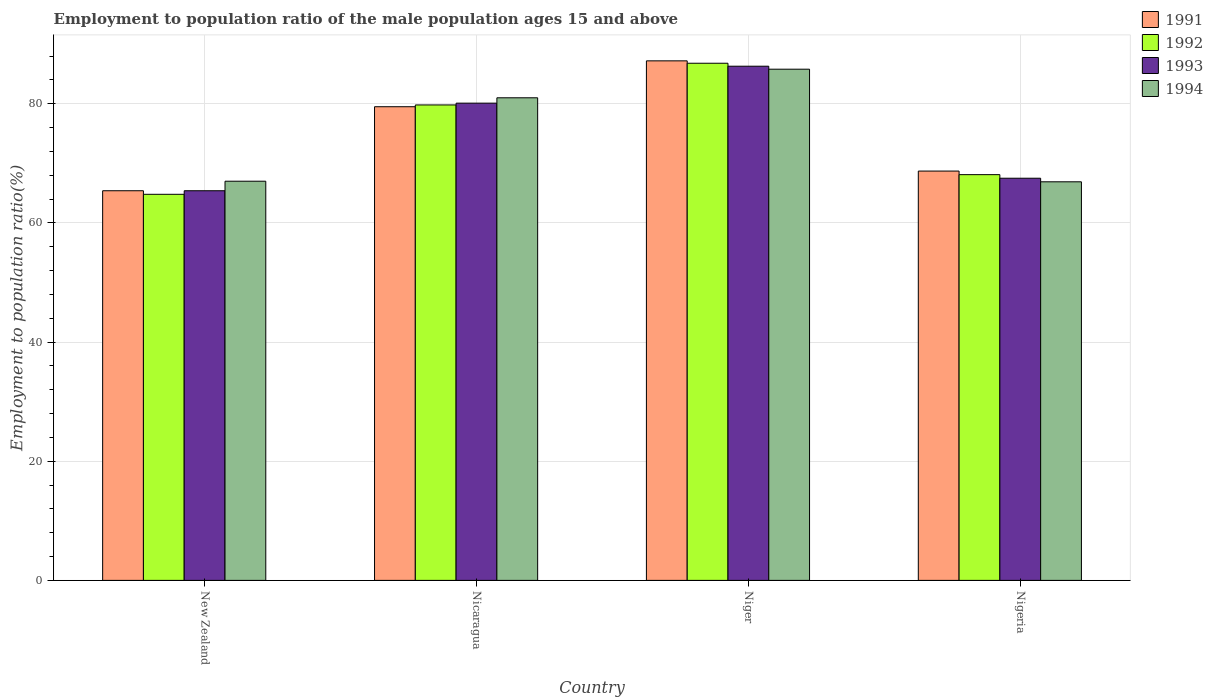How many different coloured bars are there?
Your response must be concise. 4. How many groups of bars are there?
Provide a short and direct response. 4. Are the number of bars on each tick of the X-axis equal?
Offer a terse response. Yes. How many bars are there on the 4th tick from the right?
Offer a terse response. 4. What is the label of the 2nd group of bars from the left?
Ensure brevity in your answer.  Nicaragua. In how many cases, is the number of bars for a given country not equal to the number of legend labels?
Ensure brevity in your answer.  0. What is the employment to population ratio in 1991 in Nicaragua?
Your answer should be compact. 79.5. Across all countries, what is the maximum employment to population ratio in 1991?
Make the answer very short. 87.2. Across all countries, what is the minimum employment to population ratio in 1993?
Give a very brief answer. 65.4. In which country was the employment to population ratio in 1993 maximum?
Provide a short and direct response. Niger. In which country was the employment to population ratio in 1993 minimum?
Offer a very short reply. New Zealand. What is the total employment to population ratio in 1992 in the graph?
Your response must be concise. 299.5. What is the difference between the employment to population ratio in 1993 in New Zealand and that in Nigeria?
Your response must be concise. -2.1. What is the difference between the employment to population ratio in 1991 in New Zealand and the employment to population ratio in 1992 in Nicaragua?
Provide a succinct answer. -14.4. What is the average employment to population ratio in 1991 per country?
Make the answer very short. 75.2. What is the difference between the employment to population ratio of/in 1991 and employment to population ratio of/in 1992 in Niger?
Provide a succinct answer. 0.4. What is the ratio of the employment to population ratio in 1991 in Nicaragua to that in Nigeria?
Your answer should be very brief. 1.16. Is the employment to population ratio in 1993 in Nicaragua less than that in Nigeria?
Offer a very short reply. No. Is the difference between the employment to population ratio in 1991 in Nicaragua and Nigeria greater than the difference between the employment to population ratio in 1992 in Nicaragua and Nigeria?
Your response must be concise. No. What is the difference between the highest and the second highest employment to population ratio in 1994?
Make the answer very short. 14. What is the difference between the highest and the lowest employment to population ratio in 1994?
Provide a short and direct response. 18.9. In how many countries, is the employment to population ratio in 1992 greater than the average employment to population ratio in 1992 taken over all countries?
Provide a short and direct response. 2. Is the sum of the employment to population ratio in 1991 in Nicaragua and Niger greater than the maximum employment to population ratio in 1992 across all countries?
Ensure brevity in your answer.  Yes. What does the 2nd bar from the left in Nicaragua represents?
Give a very brief answer. 1992. What does the 3rd bar from the right in New Zealand represents?
Keep it short and to the point. 1992. How many countries are there in the graph?
Your response must be concise. 4. Does the graph contain grids?
Your answer should be very brief. Yes. Where does the legend appear in the graph?
Offer a terse response. Top right. How many legend labels are there?
Your response must be concise. 4. What is the title of the graph?
Make the answer very short. Employment to population ratio of the male population ages 15 and above. What is the Employment to population ratio(%) in 1991 in New Zealand?
Offer a very short reply. 65.4. What is the Employment to population ratio(%) in 1992 in New Zealand?
Your response must be concise. 64.8. What is the Employment to population ratio(%) of 1993 in New Zealand?
Give a very brief answer. 65.4. What is the Employment to population ratio(%) of 1994 in New Zealand?
Your answer should be compact. 67. What is the Employment to population ratio(%) of 1991 in Nicaragua?
Your answer should be compact. 79.5. What is the Employment to population ratio(%) in 1992 in Nicaragua?
Make the answer very short. 79.8. What is the Employment to population ratio(%) of 1993 in Nicaragua?
Your answer should be very brief. 80.1. What is the Employment to population ratio(%) in 1991 in Niger?
Keep it short and to the point. 87.2. What is the Employment to population ratio(%) of 1992 in Niger?
Offer a very short reply. 86.8. What is the Employment to population ratio(%) of 1993 in Niger?
Keep it short and to the point. 86.3. What is the Employment to population ratio(%) of 1994 in Niger?
Your answer should be compact. 85.8. What is the Employment to population ratio(%) in 1991 in Nigeria?
Your response must be concise. 68.7. What is the Employment to population ratio(%) in 1992 in Nigeria?
Offer a terse response. 68.1. What is the Employment to population ratio(%) in 1993 in Nigeria?
Offer a terse response. 67.5. What is the Employment to population ratio(%) of 1994 in Nigeria?
Ensure brevity in your answer.  66.9. Across all countries, what is the maximum Employment to population ratio(%) in 1991?
Your response must be concise. 87.2. Across all countries, what is the maximum Employment to population ratio(%) in 1992?
Provide a short and direct response. 86.8. Across all countries, what is the maximum Employment to population ratio(%) in 1993?
Your response must be concise. 86.3. Across all countries, what is the maximum Employment to population ratio(%) in 1994?
Your answer should be compact. 85.8. Across all countries, what is the minimum Employment to population ratio(%) in 1991?
Provide a succinct answer. 65.4. Across all countries, what is the minimum Employment to population ratio(%) of 1992?
Provide a succinct answer. 64.8. Across all countries, what is the minimum Employment to population ratio(%) of 1993?
Provide a short and direct response. 65.4. Across all countries, what is the minimum Employment to population ratio(%) of 1994?
Ensure brevity in your answer.  66.9. What is the total Employment to population ratio(%) in 1991 in the graph?
Give a very brief answer. 300.8. What is the total Employment to population ratio(%) of 1992 in the graph?
Provide a short and direct response. 299.5. What is the total Employment to population ratio(%) of 1993 in the graph?
Offer a terse response. 299.3. What is the total Employment to population ratio(%) in 1994 in the graph?
Keep it short and to the point. 300.7. What is the difference between the Employment to population ratio(%) in 1991 in New Zealand and that in Nicaragua?
Give a very brief answer. -14.1. What is the difference between the Employment to population ratio(%) of 1993 in New Zealand and that in Nicaragua?
Your answer should be very brief. -14.7. What is the difference between the Employment to population ratio(%) of 1991 in New Zealand and that in Niger?
Your answer should be very brief. -21.8. What is the difference between the Employment to population ratio(%) in 1993 in New Zealand and that in Niger?
Offer a very short reply. -20.9. What is the difference between the Employment to population ratio(%) in 1994 in New Zealand and that in Niger?
Offer a very short reply. -18.8. What is the difference between the Employment to population ratio(%) of 1991 in New Zealand and that in Nigeria?
Your answer should be compact. -3.3. What is the difference between the Employment to population ratio(%) of 1993 in New Zealand and that in Nigeria?
Keep it short and to the point. -2.1. What is the difference between the Employment to population ratio(%) of 1992 in Nicaragua and that in Niger?
Provide a succinct answer. -7. What is the difference between the Employment to population ratio(%) in 1993 in Nicaragua and that in Niger?
Your response must be concise. -6.2. What is the difference between the Employment to population ratio(%) in 1994 in Nicaragua and that in Niger?
Make the answer very short. -4.8. What is the difference between the Employment to population ratio(%) in 1991 in Niger and that in Nigeria?
Your response must be concise. 18.5. What is the difference between the Employment to population ratio(%) of 1992 in Niger and that in Nigeria?
Your answer should be very brief. 18.7. What is the difference between the Employment to population ratio(%) of 1993 in Niger and that in Nigeria?
Keep it short and to the point. 18.8. What is the difference between the Employment to population ratio(%) in 1991 in New Zealand and the Employment to population ratio(%) in 1992 in Nicaragua?
Offer a very short reply. -14.4. What is the difference between the Employment to population ratio(%) of 1991 in New Zealand and the Employment to population ratio(%) of 1993 in Nicaragua?
Provide a short and direct response. -14.7. What is the difference between the Employment to population ratio(%) in 1991 in New Zealand and the Employment to population ratio(%) in 1994 in Nicaragua?
Provide a short and direct response. -15.6. What is the difference between the Employment to population ratio(%) in 1992 in New Zealand and the Employment to population ratio(%) in 1993 in Nicaragua?
Provide a succinct answer. -15.3. What is the difference between the Employment to population ratio(%) in 1992 in New Zealand and the Employment to population ratio(%) in 1994 in Nicaragua?
Your answer should be compact. -16.2. What is the difference between the Employment to population ratio(%) in 1993 in New Zealand and the Employment to population ratio(%) in 1994 in Nicaragua?
Your answer should be very brief. -15.6. What is the difference between the Employment to population ratio(%) in 1991 in New Zealand and the Employment to population ratio(%) in 1992 in Niger?
Ensure brevity in your answer.  -21.4. What is the difference between the Employment to population ratio(%) of 1991 in New Zealand and the Employment to population ratio(%) of 1993 in Niger?
Offer a very short reply. -20.9. What is the difference between the Employment to population ratio(%) of 1991 in New Zealand and the Employment to population ratio(%) of 1994 in Niger?
Ensure brevity in your answer.  -20.4. What is the difference between the Employment to population ratio(%) in 1992 in New Zealand and the Employment to population ratio(%) in 1993 in Niger?
Your answer should be compact. -21.5. What is the difference between the Employment to population ratio(%) of 1993 in New Zealand and the Employment to population ratio(%) of 1994 in Niger?
Keep it short and to the point. -20.4. What is the difference between the Employment to population ratio(%) of 1991 in New Zealand and the Employment to population ratio(%) of 1992 in Nigeria?
Provide a succinct answer. -2.7. What is the difference between the Employment to population ratio(%) of 1991 in New Zealand and the Employment to population ratio(%) of 1993 in Nigeria?
Provide a succinct answer. -2.1. What is the difference between the Employment to population ratio(%) of 1991 in New Zealand and the Employment to population ratio(%) of 1994 in Nigeria?
Give a very brief answer. -1.5. What is the difference between the Employment to population ratio(%) in 1992 in New Zealand and the Employment to population ratio(%) in 1994 in Nigeria?
Ensure brevity in your answer.  -2.1. What is the difference between the Employment to population ratio(%) in 1991 in Nicaragua and the Employment to population ratio(%) in 1993 in Niger?
Your response must be concise. -6.8. What is the difference between the Employment to population ratio(%) of 1991 in Nicaragua and the Employment to population ratio(%) of 1994 in Niger?
Offer a very short reply. -6.3. What is the difference between the Employment to population ratio(%) in 1992 in Nicaragua and the Employment to population ratio(%) in 1994 in Niger?
Ensure brevity in your answer.  -6. What is the difference between the Employment to population ratio(%) of 1991 in Nicaragua and the Employment to population ratio(%) of 1994 in Nigeria?
Your answer should be compact. 12.6. What is the difference between the Employment to population ratio(%) of 1991 in Niger and the Employment to population ratio(%) of 1993 in Nigeria?
Your answer should be compact. 19.7. What is the difference between the Employment to population ratio(%) of 1991 in Niger and the Employment to population ratio(%) of 1994 in Nigeria?
Your response must be concise. 20.3. What is the difference between the Employment to population ratio(%) of 1992 in Niger and the Employment to population ratio(%) of 1993 in Nigeria?
Provide a short and direct response. 19.3. What is the difference between the Employment to population ratio(%) of 1992 in Niger and the Employment to population ratio(%) of 1994 in Nigeria?
Keep it short and to the point. 19.9. What is the average Employment to population ratio(%) of 1991 per country?
Provide a short and direct response. 75.2. What is the average Employment to population ratio(%) of 1992 per country?
Make the answer very short. 74.88. What is the average Employment to population ratio(%) of 1993 per country?
Offer a terse response. 74.83. What is the average Employment to population ratio(%) in 1994 per country?
Ensure brevity in your answer.  75.17. What is the difference between the Employment to population ratio(%) in 1991 and Employment to population ratio(%) in 1993 in New Zealand?
Keep it short and to the point. 0. What is the difference between the Employment to population ratio(%) in 1992 and Employment to population ratio(%) in 1994 in New Zealand?
Offer a very short reply. -2.2. What is the difference between the Employment to population ratio(%) of 1991 and Employment to population ratio(%) of 1992 in Nicaragua?
Your response must be concise. -0.3. What is the difference between the Employment to population ratio(%) of 1991 and Employment to population ratio(%) of 1993 in Nicaragua?
Provide a succinct answer. -0.6. What is the difference between the Employment to population ratio(%) in 1991 and Employment to population ratio(%) in 1994 in Nicaragua?
Your answer should be compact. -1.5. What is the difference between the Employment to population ratio(%) in 1993 and Employment to population ratio(%) in 1994 in Nicaragua?
Ensure brevity in your answer.  -0.9. What is the difference between the Employment to population ratio(%) of 1992 and Employment to population ratio(%) of 1993 in Niger?
Keep it short and to the point. 0.5. What is the difference between the Employment to population ratio(%) of 1992 and Employment to population ratio(%) of 1994 in Niger?
Provide a succinct answer. 1. What is the difference between the Employment to population ratio(%) in 1993 and Employment to population ratio(%) in 1994 in Niger?
Give a very brief answer. 0.5. What is the difference between the Employment to population ratio(%) of 1991 and Employment to population ratio(%) of 1992 in Nigeria?
Offer a very short reply. 0.6. What is the difference between the Employment to population ratio(%) in 1991 and Employment to population ratio(%) in 1993 in Nigeria?
Offer a very short reply. 1.2. What is the ratio of the Employment to population ratio(%) in 1991 in New Zealand to that in Nicaragua?
Make the answer very short. 0.82. What is the ratio of the Employment to population ratio(%) of 1992 in New Zealand to that in Nicaragua?
Keep it short and to the point. 0.81. What is the ratio of the Employment to population ratio(%) of 1993 in New Zealand to that in Nicaragua?
Your answer should be compact. 0.82. What is the ratio of the Employment to population ratio(%) in 1994 in New Zealand to that in Nicaragua?
Your answer should be very brief. 0.83. What is the ratio of the Employment to population ratio(%) of 1992 in New Zealand to that in Niger?
Your answer should be compact. 0.75. What is the ratio of the Employment to population ratio(%) in 1993 in New Zealand to that in Niger?
Give a very brief answer. 0.76. What is the ratio of the Employment to population ratio(%) of 1994 in New Zealand to that in Niger?
Your answer should be compact. 0.78. What is the ratio of the Employment to population ratio(%) in 1991 in New Zealand to that in Nigeria?
Make the answer very short. 0.95. What is the ratio of the Employment to population ratio(%) in 1992 in New Zealand to that in Nigeria?
Provide a short and direct response. 0.95. What is the ratio of the Employment to population ratio(%) of 1993 in New Zealand to that in Nigeria?
Offer a very short reply. 0.97. What is the ratio of the Employment to population ratio(%) of 1994 in New Zealand to that in Nigeria?
Give a very brief answer. 1. What is the ratio of the Employment to population ratio(%) in 1991 in Nicaragua to that in Niger?
Give a very brief answer. 0.91. What is the ratio of the Employment to population ratio(%) in 1992 in Nicaragua to that in Niger?
Offer a very short reply. 0.92. What is the ratio of the Employment to population ratio(%) of 1993 in Nicaragua to that in Niger?
Provide a succinct answer. 0.93. What is the ratio of the Employment to population ratio(%) of 1994 in Nicaragua to that in Niger?
Offer a very short reply. 0.94. What is the ratio of the Employment to population ratio(%) of 1991 in Nicaragua to that in Nigeria?
Offer a terse response. 1.16. What is the ratio of the Employment to population ratio(%) of 1992 in Nicaragua to that in Nigeria?
Give a very brief answer. 1.17. What is the ratio of the Employment to population ratio(%) of 1993 in Nicaragua to that in Nigeria?
Your response must be concise. 1.19. What is the ratio of the Employment to population ratio(%) in 1994 in Nicaragua to that in Nigeria?
Provide a short and direct response. 1.21. What is the ratio of the Employment to population ratio(%) of 1991 in Niger to that in Nigeria?
Keep it short and to the point. 1.27. What is the ratio of the Employment to population ratio(%) in 1992 in Niger to that in Nigeria?
Provide a succinct answer. 1.27. What is the ratio of the Employment to population ratio(%) in 1993 in Niger to that in Nigeria?
Offer a terse response. 1.28. What is the ratio of the Employment to population ratio(%) in 1994 in Niger to that in Nigeria?
Provide a short and direct response. 1.28. What is the difference between the highest and the second highest Employment to population ratio(%) of 1991?
Give a very brief answer. 7.7. What is the difference between the highest and the second highest Employment to population ratio(%) of 1993?
Keep it short and to the point. 6.2. What is the difference between the highest and the second highest Employment to population ratio(%) of 1994?
Provide a short and direct response. 4.8. What is the difference between the highest and the lowest Employment to population ratio(%) in 1991?
Give a very brief answer. 21.8. What is the difference between the highest and the lowest Employment to population ratio(%) of 1993?
Your answer should be compact. 20.9. What is the difference between the highest and the lowest Employment to population ratio(%) in 1994?
Provide a succinct answer. 18.9. 